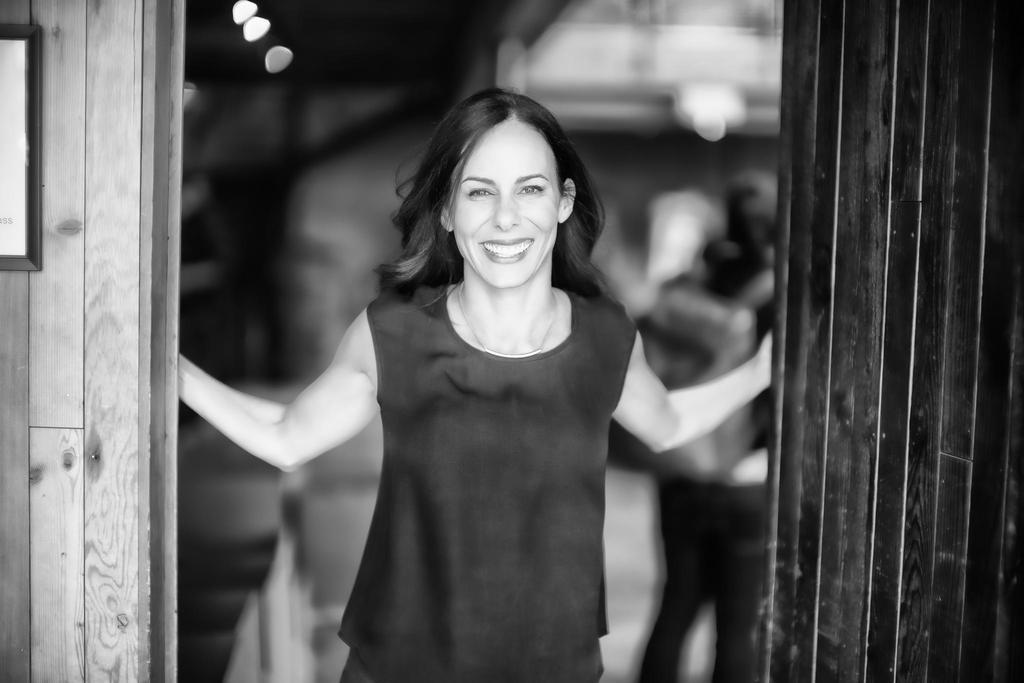What is the color scheme of the image? The image is black and white. What can be seen in the foreground of the image? There is a woman standing in the image. What is the woman's facial expression? The woman is smiling. What is attached to the wall in the image? There is a frame attached to the wall in the image. How would you describe the background of the image? The background of the image is blurred. What type of cloth is draped over the box in the image? There is no box or cloth present in the image. 